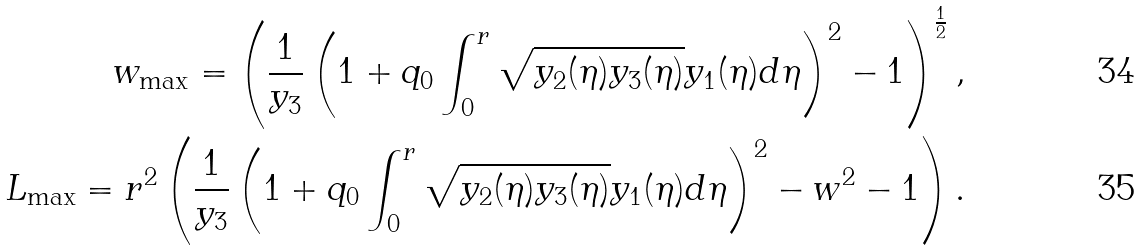Convert formula to latex. <formula><loc_0><loc_0><loc_500><loc_500>w _ { \max } = \left ( \frac { 1 } { y _ { 3 } } \left ( 1 + q _ { 0 } \int _ { 0 } ^ { r } \sqrt { y _ { 2 } ( \eta ) y _ { 3 } ( \eta ) } y _ { 1 } ( \eta ) d \eta \right ) ^ { 2 } - 1 \right ) ^ { \frac { 1 } { 2 } } , \\ L _ { \max } = r ^ { 2 } \left ( \frac { 1 } { y _ { 3 } } \left ( 1 + q _ { 0 } \int _ { 0 } ^ { r } \sqrt { y _ { 2 } ( \eta ) y _ { 3 } ( \eta ) } y _ { 1 } ( \eta ) d \eta \right ) ^ { 2 } - w ^ { 2 } - 1 \right ) .</formula> 